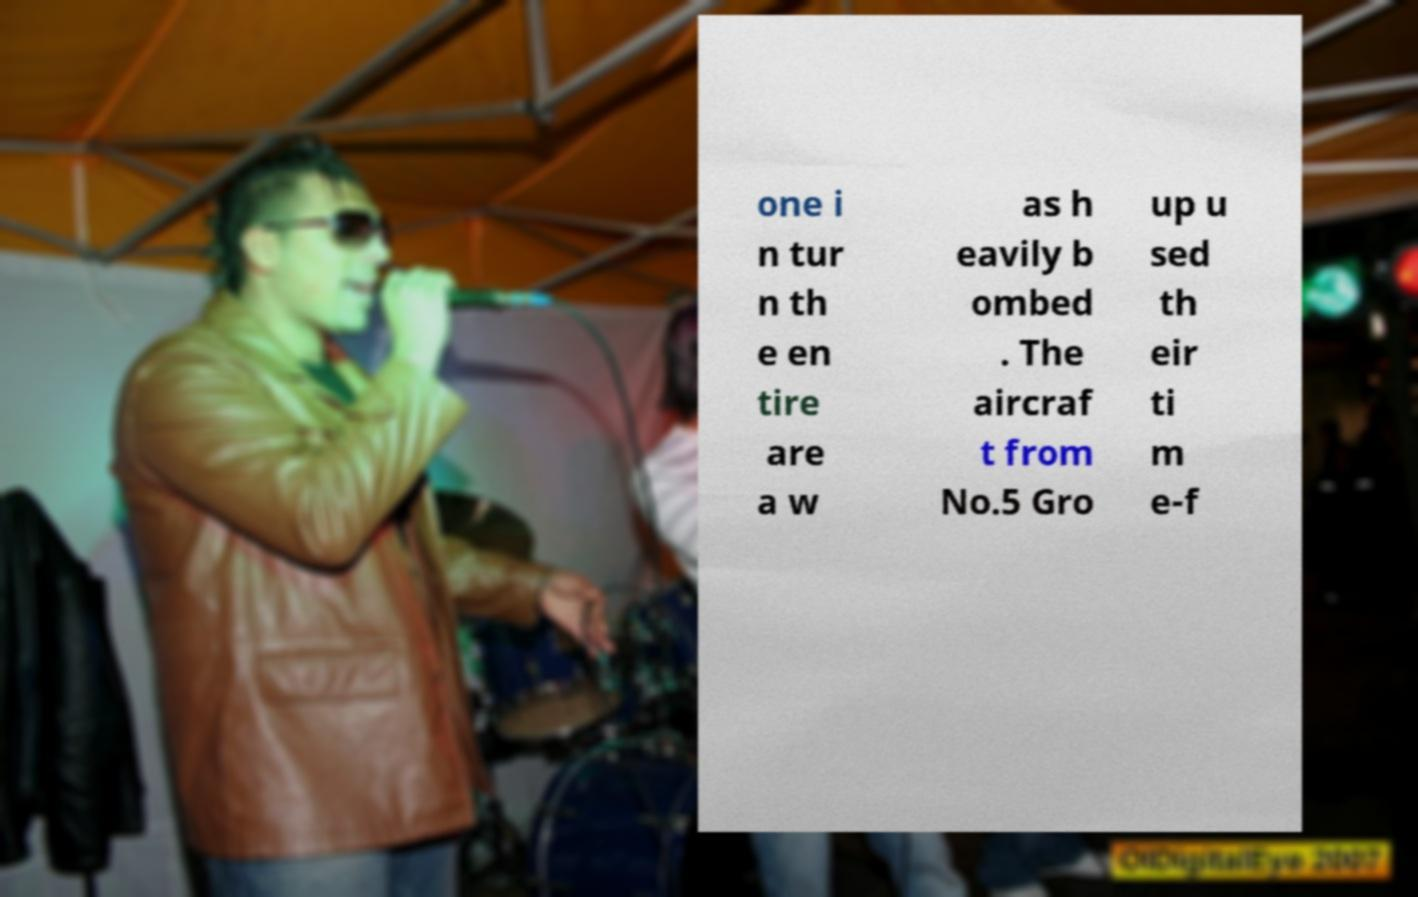What messages or text are displayed in this image? I need them in a readable, typed format. one i n tur n th e en tire are a w as h eavily b ombed . The aircraf t from No.5 Gro up u sed th eir ti m e-f 